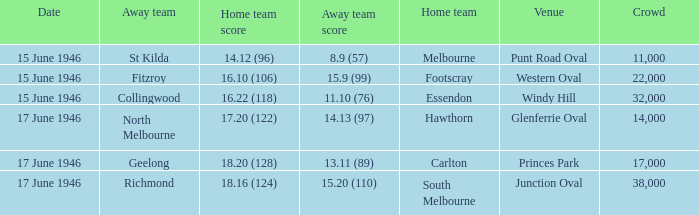12 (96)? Melbourne. 